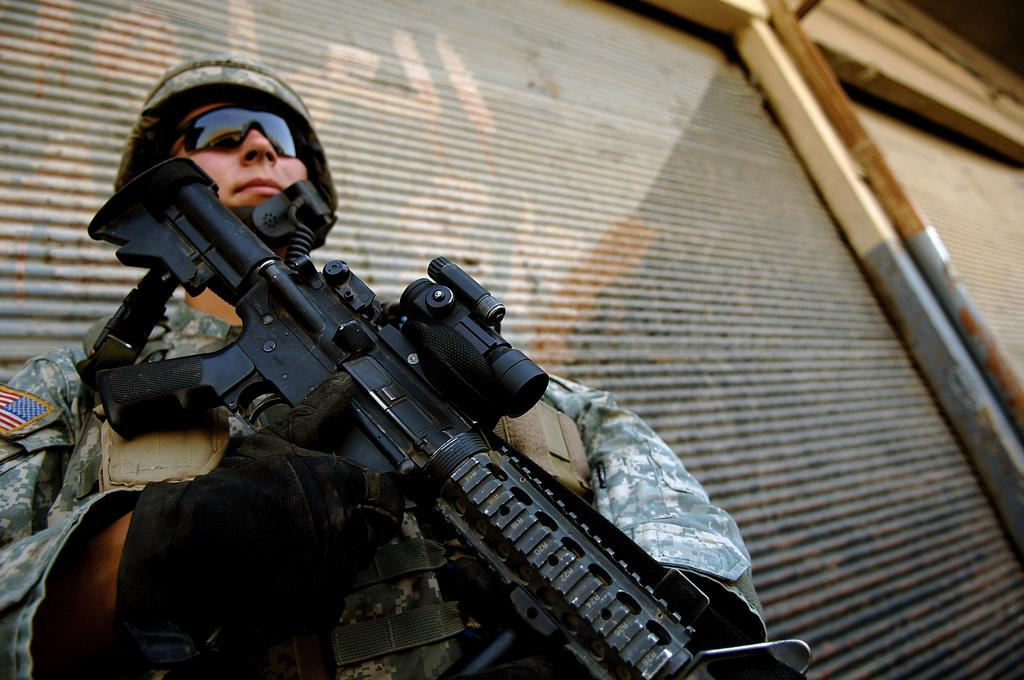What is the main subject of the image? There is a person in the image. What can be observed about the person's attire? The person is wearing a uniform. What is the person doing in the image? The person is standing and holding a gun. Can you describe the gun? The gun is black in color. What can be seen in the background of the image? There are two rolling shutters in the background of the image. What is the plot of the story unfolding in the image? There is no story or plot depicted in the image; it is a static representation of a person standing with a gun. Who are the friends of the person in the image? There is no indication of friends or any social context in the image; it only shows a person standing with a gun. 